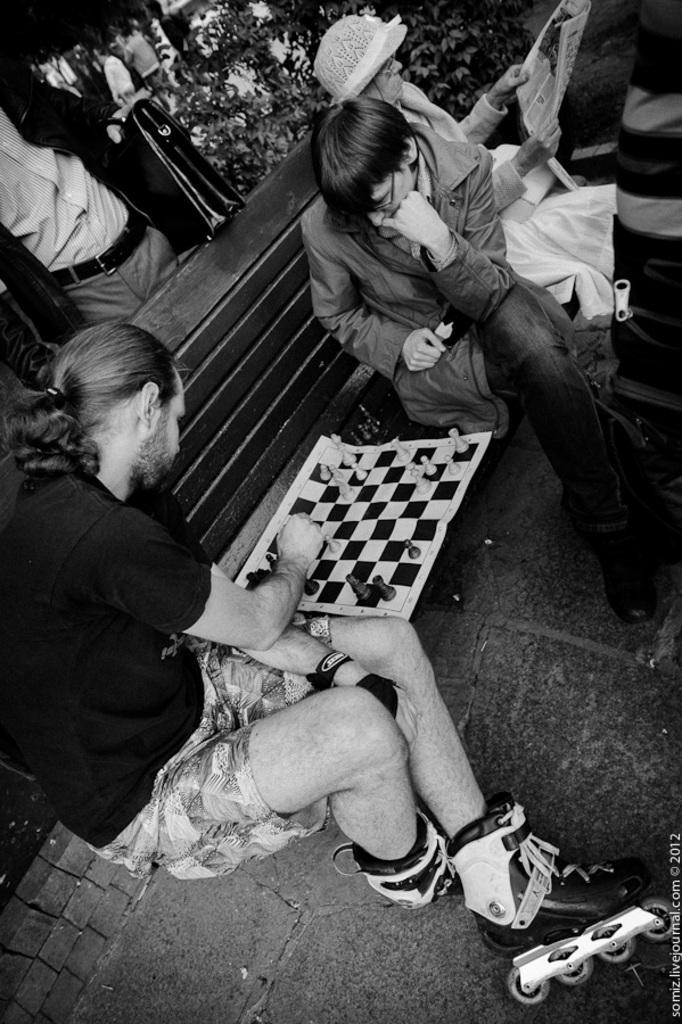Please provide a concise description of this image. In the picture I can see people among them some are standing on the ground and some are sitting on a wooden bench. I can also see chess board and chess pieces on the bench. This picture is black and white in color. On the bottom right corner of the image I can see a watermark. 